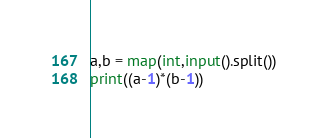<code> <loc_0><loc_0><loc_500><loc_500><_Python_>a,b = map(int,input().split())
print((a-1)*(b-1))</code> 